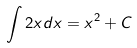<formula> <loc_0><loc_0><loc_500><loc_500>\int 2 x d x = x ^ { 2 } + C</formula> 